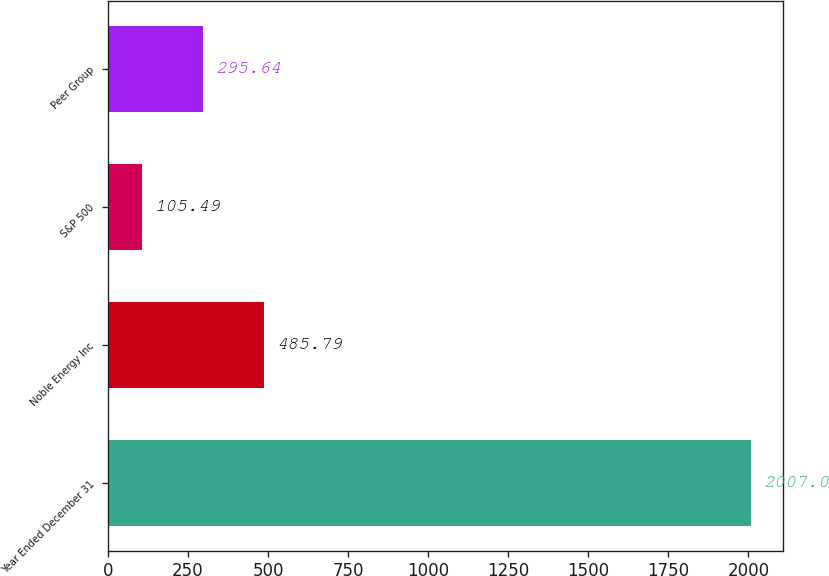Convert chart to OTSL. <chart><loc_0><loc_0><loc_500><loc_500><bar_chart><fcel>Year Ended December 31<fcel>Noble Energy Inc<fcel>S&P 500<fcel>Peer Group<nl><fcel>2007<fcel>485.79<fcel>105.49<fcel>295.64<nl></chart> 